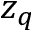<formula> <loc_0><loc_0><loc_500><loc_500>z _ { q }</formula> 